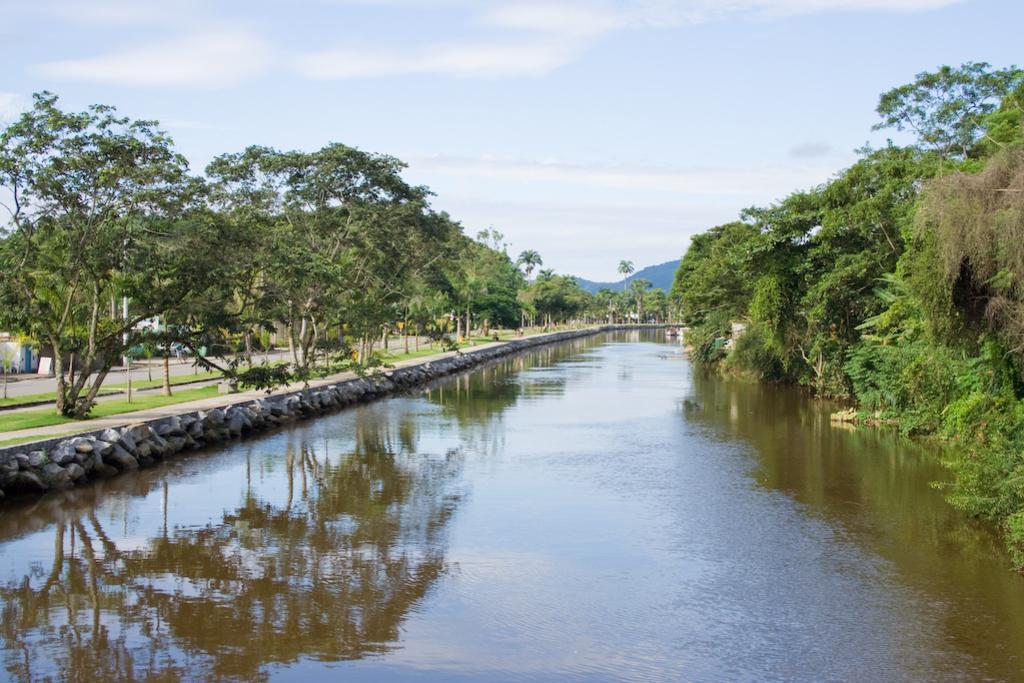Can you describe this image briefly? In this image I can see the water. To the side of the water I can see many trees and the road. In the background I can see mountains, clouds and the sky. 